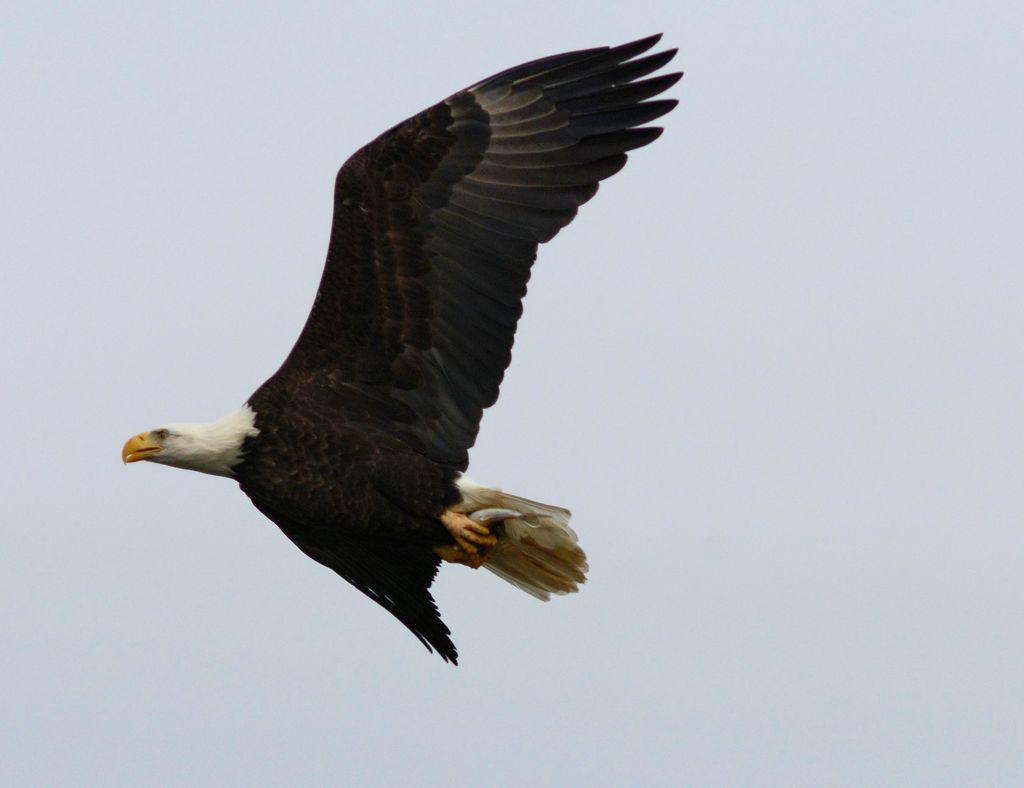What is the main subject in the center of the image? There is an eagle in the center of the image. What can be seen in the background of the image? There is sky visible in the background of the image. What type of structure can be seen near the coast in the image? There is no structure or coast present in the image; it features an eagle in the sky. 